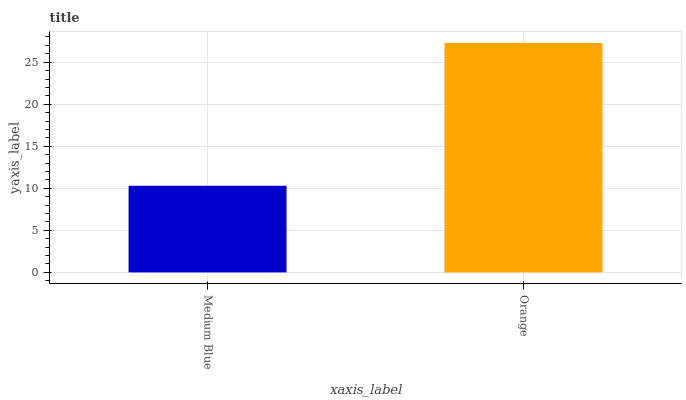Is Medium Blue the minimum?
Answer yes or no. Yes. Is Orange the maximum?
Answer yes or no. Yes. Is Orange the minimum?
Answer yes or no. No. Is Orange greater than Medium Blue?
Answer yes or no. Yes. Is Medium Blue less than Orange?
Answer yes or no. Yes. Is Medium Blue greater than Orange?
Answer yes or no. No. Is Orange less than Medium Blue?
Answer yes or no. No. Is Orange the high median?
Answer yes or no. Yes. Is Medium Blue the low median?
Answer yes or no. Yes. Is Medium Blue the high median?
Answer yes or no. No. Is Orange the low median?
Answer yes or no. No. 